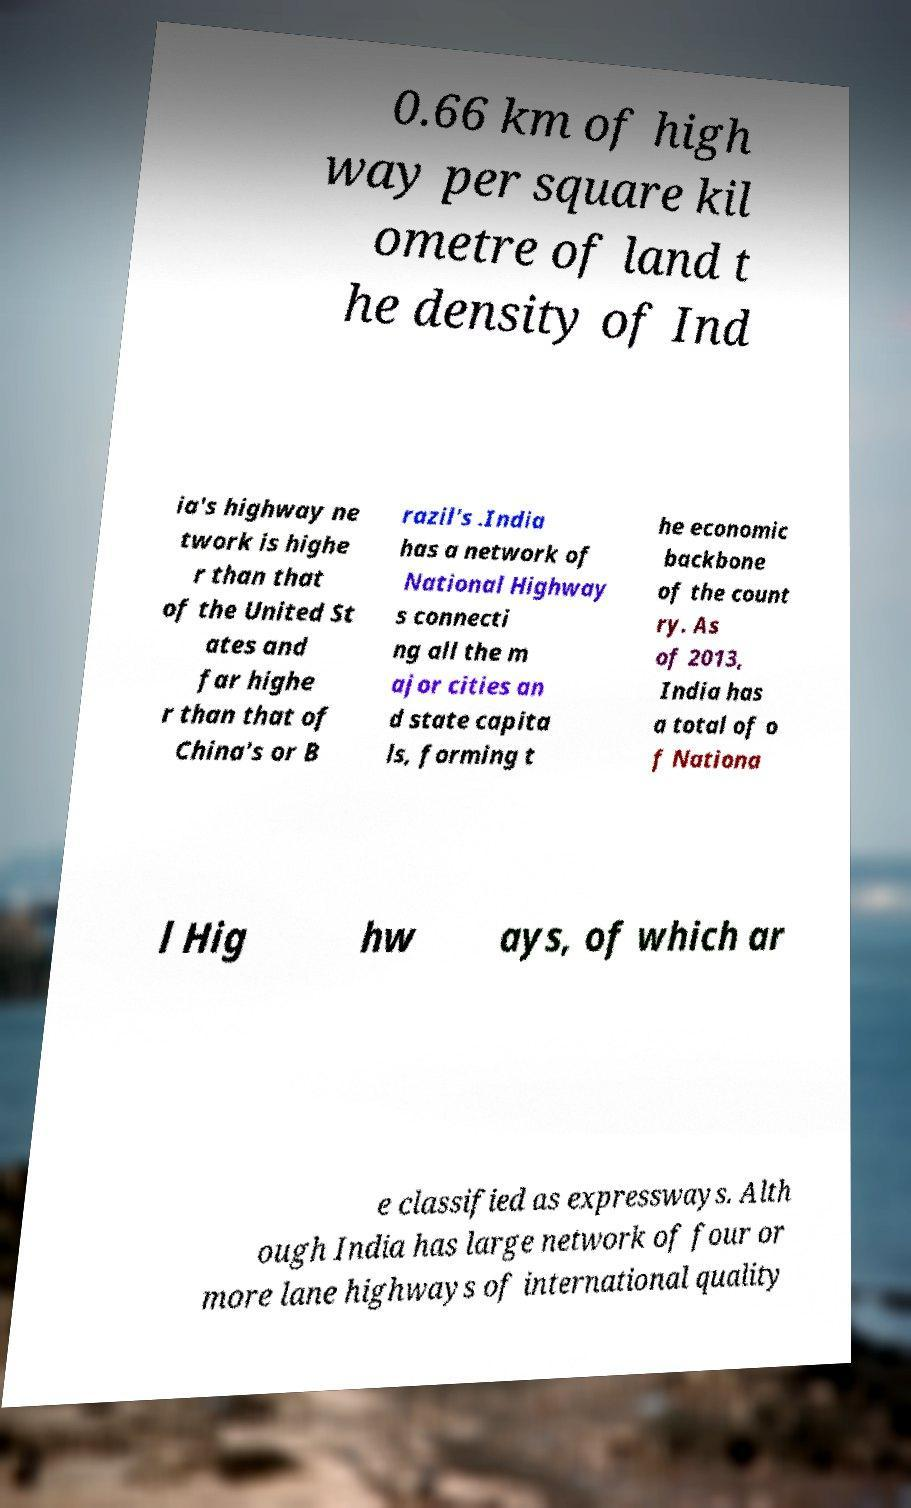Please read and relay the text visible in this image. What does it say? 0.66 km of high way per square kil ometre of land t he density of Ind ia's highway ne twork is highe r than that of the United St ates and far highe r than that of China's or B razil's .India has a network of National Highway s connecti ng all the m ajor cities an d state capita ls, forming t he economic backbone of the count ry. As of 2013, India has a total of o f Nationa l Hig hw ays, of which ar e classified as expressways. Alth ough India has large network of four or more lane highways of international quality 